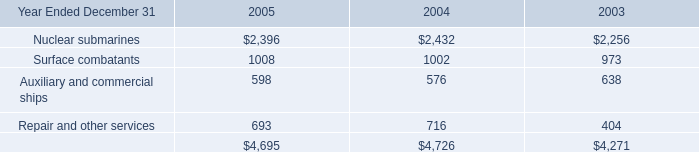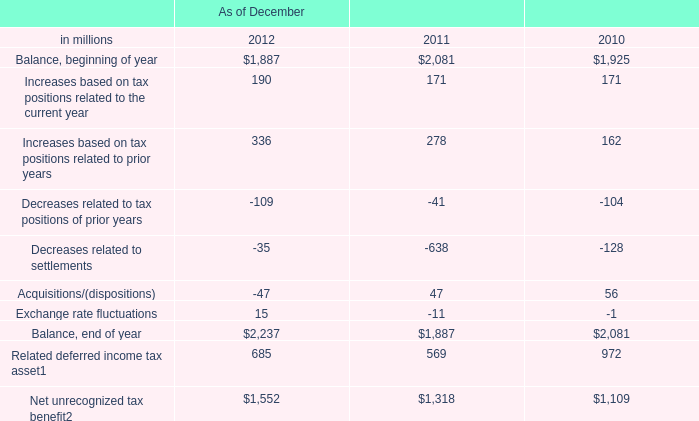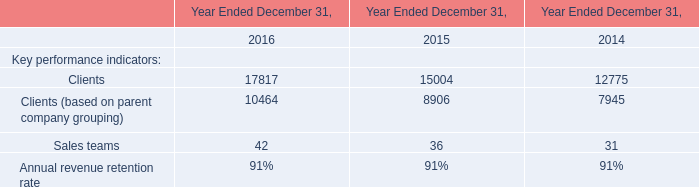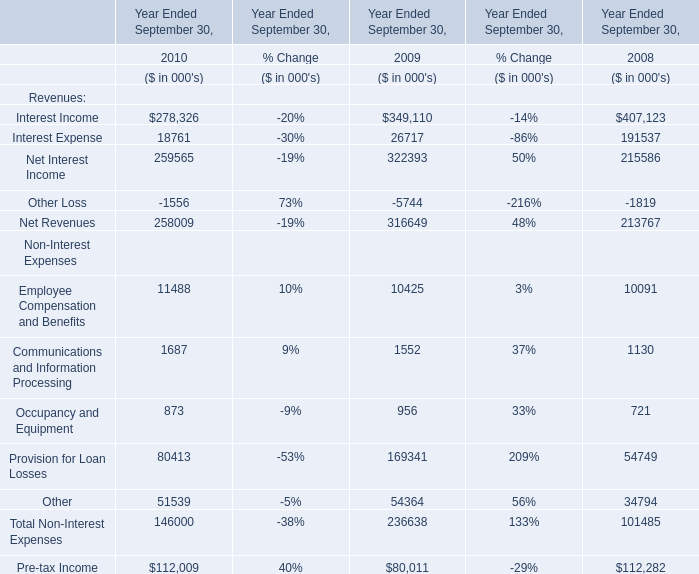What is the average amount of Clients of Year Ended December 31, 2014, and Balance, end of year of As of December 2012 ? 
Computations: ((12775.0 + 2237.0) / 2)
Answer: 7506.0. 